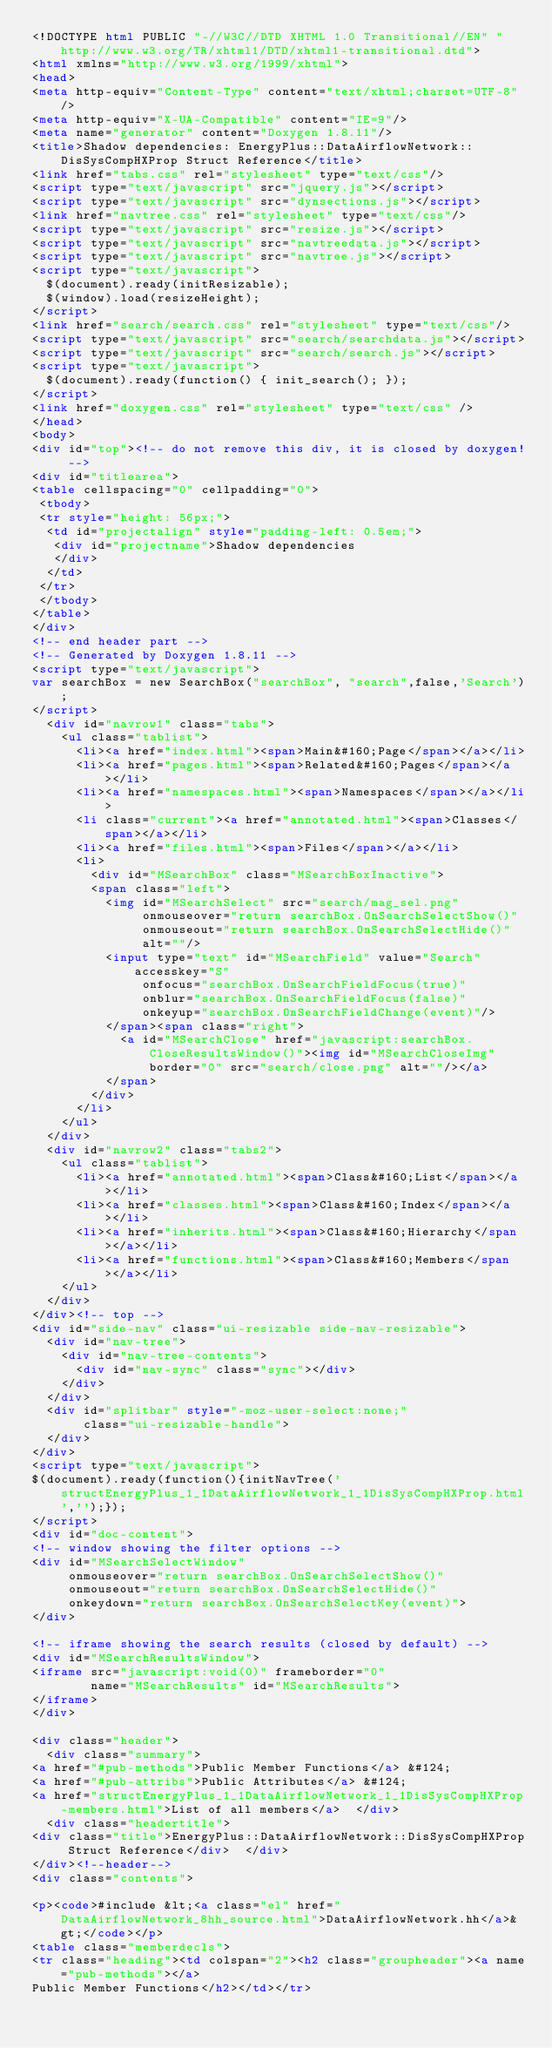Convert code to text. <code><loc_0><loc_0><loc_500><loc_500><_HTML_><!DOCTYPE html PUBLIC "-//W3C//DTD XHTML 1.0 Transitional//EN" "http://www.w3.org/TR/xhtml1/DTD/xhtml1-transitional.dtd">
<html xmlns="http://www.w3.org/1999/xhtml">
<head>
<meta http-equiv="Content-Type" content="text/xhtml;charset=UTF-8"/>
<meta http-equiv="X-UA-Compatible" content="IE=9"/>
<meta name="generator" content="Doxygen 1.8.11"/>
<title>Shadow dependencies: EnergyPlus::DataAirflowNetwork::DisSysCompHXProp Struct Reference</title>
<link href="tabs.css" rel="stylesheet" type="text/css"/>
<script type="text/javascript" src="jquery.js"></script>
<script type="text/javascript" src="dynsections.js"></script>
<link href="navtree.css" rel="stylesheet" type="text/css"/>
<script type="text/javascript" src="resize.js"></script>
<script type="text/javascript" src="navtreedata.js"></script>
<script type="text/javascript" src="navtree.js"></script>
<script type="text/javascript">
  $(document).ready(initResizable);
  $(window).load(resizeHeight);
</script>
<link href="search/search.css" rel="stylesheet" type="text/css"/>
<script type="text/javascript" src="search/searchdata.js"></script>
<script type="text/javascript" src="search/search.js"></script>
<script type="text/javascript">
  $(document).ready(function() { init_search(); });
</script>
<link href="doxygen.css" rel="stylesheet" type="text/css" />
</head>
<body>
<div id="top"><!-- do not remove this div, it is closed by doxygen! -->
<div id="titlearea">
<table cellspacing="0" cellpadding="0">
 <tbody>
 <tr style="height: 56px;">
  <td id="projectalign" style="padding-left: 0.5em;">
   <div id="projectname">Shadow dependencies
   </div>
  </td>
 </tr>
 </tbody>
</table>
</div>
<!-- end header part -->
<!-- Generated by Doxygen 1.8.11 -->
<script type="text/javascript">
var searchBox = new SearchBox("searchBox", "search",false,'Search');
</script>
  <div id="navrow1" class="tabs">
    <ul class="tablist">
      <li><a href="index.html"><span>Main&#160;Page</span></a></li>
      <li><a href="pages.html"><span>Related&#160;Pages</span></a></li>
      <li><a href="namespaces.html"><span>Namespaces</span></a></li>
      <li class="current"><a href="annotated.html"><span>Classes</span></a></li>
      <li><a href="files.html"><span>Files</span></a></li>
      <li>
        <div id="MSearchBox" class="MSearchBoxInactive">
        <span class="left">
          <img id="MSearchSelect" src="search/mag_sel.png"
               onmouseover="return searchBox.OnSearchSelectShow()"
               onmouseout="return searchBox.OnSearchSelectHide()"
               alt=""/>
          <input type="text" id="MSearchField" value="Search" accesskey="S"
               onfocus="searchBox.OnSearchFieldFocus(true)" 
               onblur="searchBox.OnSearchFieldFocus(false)" 
               onkeyup="searchBox.OnSearchFieldChange(event)"/>
          </span><span class="right">
            <a id="MSearchClose" href="javascript:searchBox.CloseResultsWindow()"><img id="MSearchCloseImg" border="0" src="search/close.png" alt=""/></a>
          </span>
        </div>
      </li>
    </ul>
  </div>
  <div id="navrow2" class="tabs2">
    <ul class="tablist">
      <li><a href="annotated.html"><span>Class&#160;List</span></a></li>
      <li><a href="classes.html"><span>Class&#160;Index</span></a></li>
      <li><a href="inherits.html"><span>Class&#160;Hierarchy</span></a></li>
      <li><a href="functions.html"><span>Class&#160;Members</span></a></li>
    </ul>
  </div>
</div><!-- top -->
<div id="side-nav" class="ui-resizable side-nav-resizable">
  <div id="nav-tree">
    <div id="nav-tree-contents">
      <div id="nav-sync" class="sync"></div>
    </div>
  </div>
  <div id="splitbar" style="-moz-user-select:none;" 
       class="ui-resizable-handle">
  </div>
</div>
<script type="text/javascript">
$(document).ready(function(){initNavTree('structEnergyPlus_1_1DataAirflowNetwork_1_1DisSysCompHXProp.html','');});
</script>
<div id="doc-content">
<!-- window showing the filter options -->
<div id="MSearchSelectWindow"
     onmouseover="return searchBox.OnSearchSelectShow()"
     onmouseout="return searchBox.OnSearchSelectHide()"
     onkeydown="return searchBox.OnSearchSelectKey(event)">
</div>

<!-- iframe showing the search results (closed by default) -->
<div id="MSearchResultsWindow">
<iframe src="javascript:void(0)" frameborder="0" 
        name="MSearchResults" id="MSearchResults">
</iframe>
</div>

<div class="header">
  <div class="summary">
<a href="#pub-methods">Public Member Functions</a> &#124;
<a href="#pub-attribs">Public Attributes</a> &#124;
<a href="structEnergyPlus_1_1DataAirflowNetwork_1_1DisSysCompHXProp-members.html">List of all members</a>  </div>
  <div class="headertitle">
<div class="title">EnergyPlus::DataAirflowNetwork::DisSysCompHXProp Struct Reference</div>  </div>
</div><!--header-->
<div class="contents">

<p><code>#include &lt;<a class="el" href="DataAirflowNetwork_8hh_source.html">DataAirflowNetwork.hh</a>&gt;</code></p>
<table class="memberdecls">
<tr class="heading"><td colspan="2"><h2 class="groupheader"><a name="pub-methods"></a>
Public Member Functions</h2></td></tr></code> 